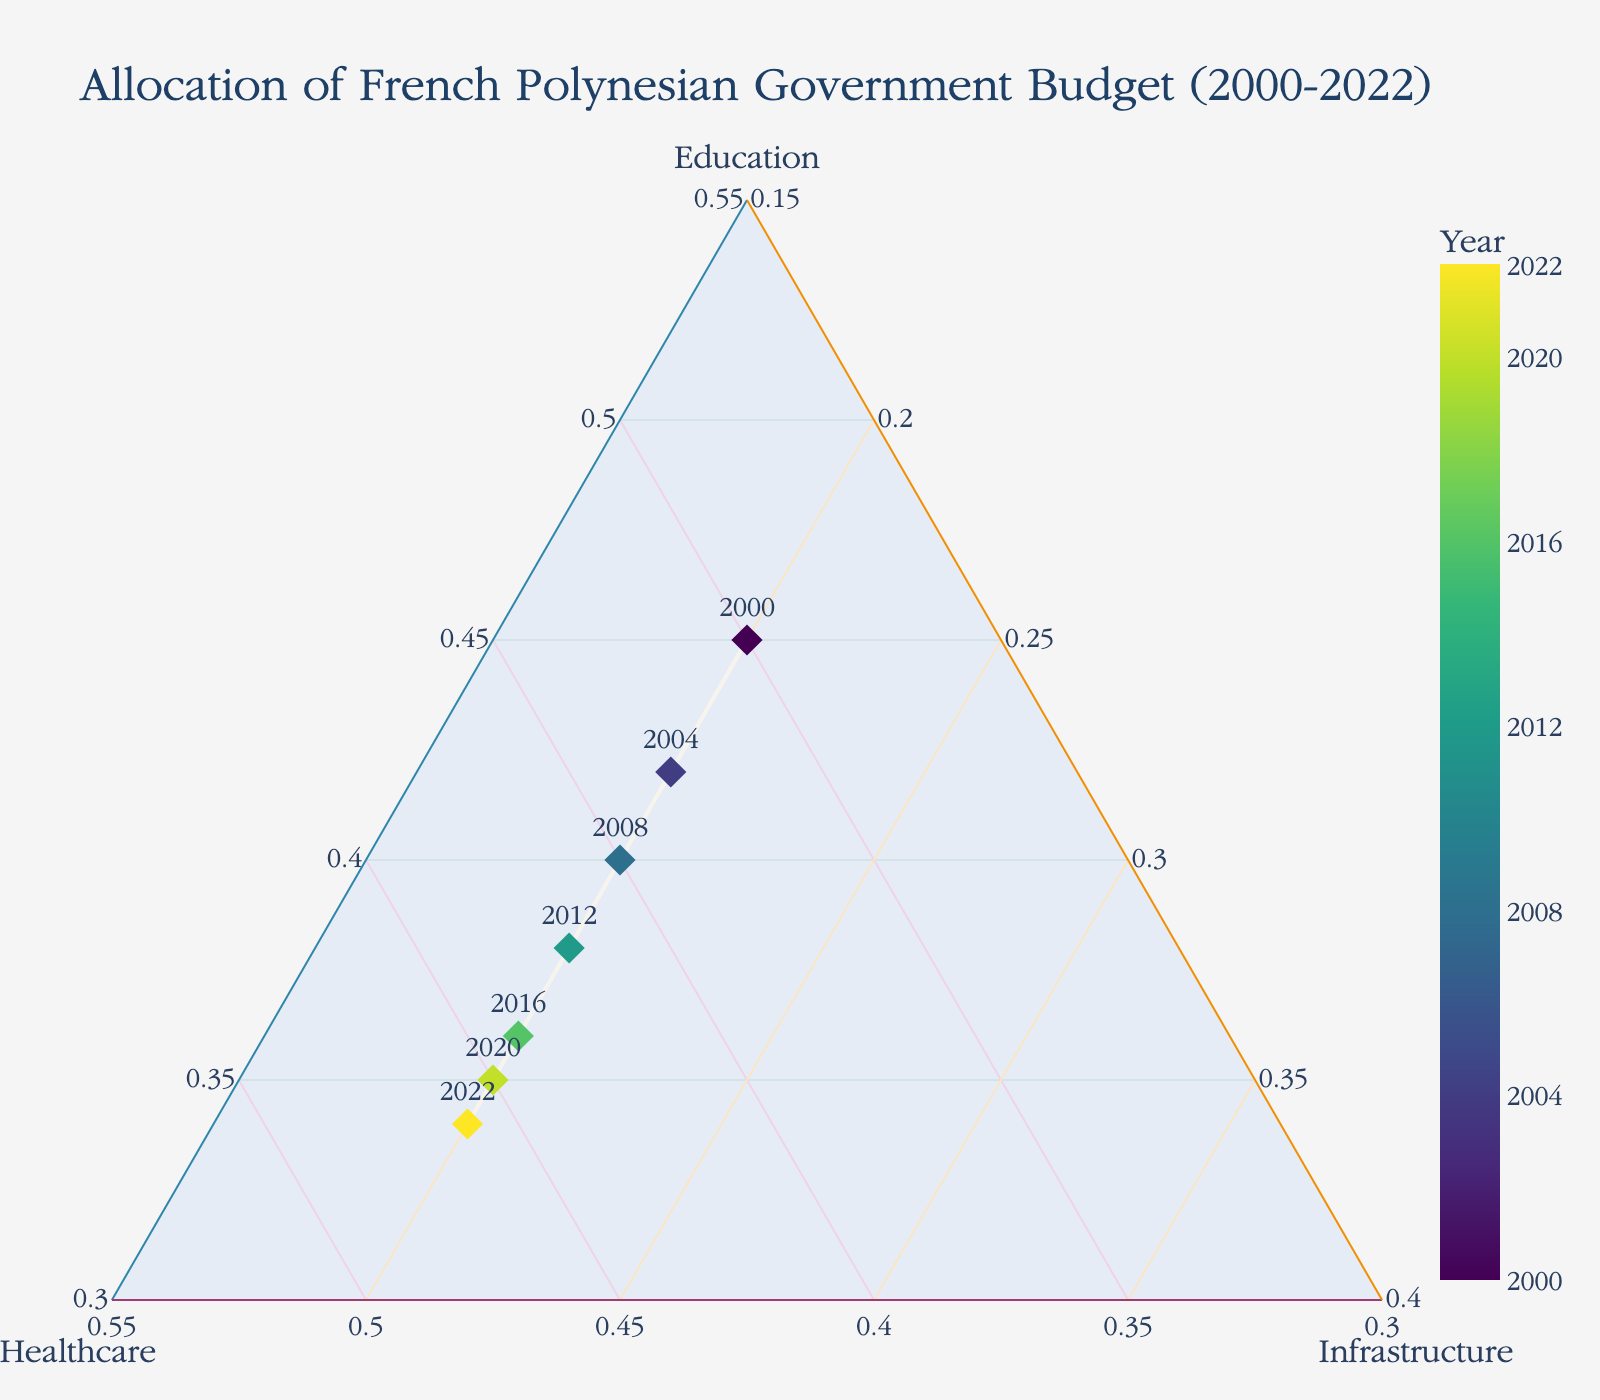what year is represented with the highest allocation to healthcare? The year data point with the highest visually distinctive allocation towards healthcare will lie furthest along the Healthcare axis. Observe the point which aligns highest on the Healthcare axis.
Answer: 2022 What is the general trend in the allocation towards infrastructure over the years? By looking at the positions along the Infrastructure axis, observe whether the data points for different years move closer or further away from the Infrastructure axis. From the plot’s data points, the budget allocation towards infrastructure remains relatively constant.
Answer: Remains Constant Comparing 2000 and 2020, which year had a higher allocation towards education? Locate the data points for 2000 and 2020 on the plot. Observe their positions along the Education axis. The point closer to the Education axis indicates a higher allocation towards education. Compare the positions to find the answer.
Answer: 2000 How does the allocation towards healthcare in 2016 compare with that in 2008? Identify and compare the positions of the data points for 2016 and 2008 along the Healthcare axis. The data point that extends further along the Healthcare axis has a higher allocation towards healthcare.
Answer: Higher in 2016 What is the trend in the allocation towards education from 2000 to 2022? Observe the positions of the data points from 2000 to 2022 along the Education axis. If the points move closer to or further from the Education axis over the years, it indicates a decrease or increase in the allocation towards education, respectively. The plot shows a descending trend from 2000 to 2022.
Answer: Decreasing Between which consecutive years was the smallest change in education allocation observed? Calculate the difference in education allocation percentages between each year and identify the smallest change: 2000-2004: -3%, 2004-2008: -2%, 2008-2012: -2%, 2012-2016: -2%, 2016-2020: -1%, 2020-2022: -1%. The smallest changes are between 2016-2020 and 2020-2022.
Answer: 2016-2020 and 2020-2022 